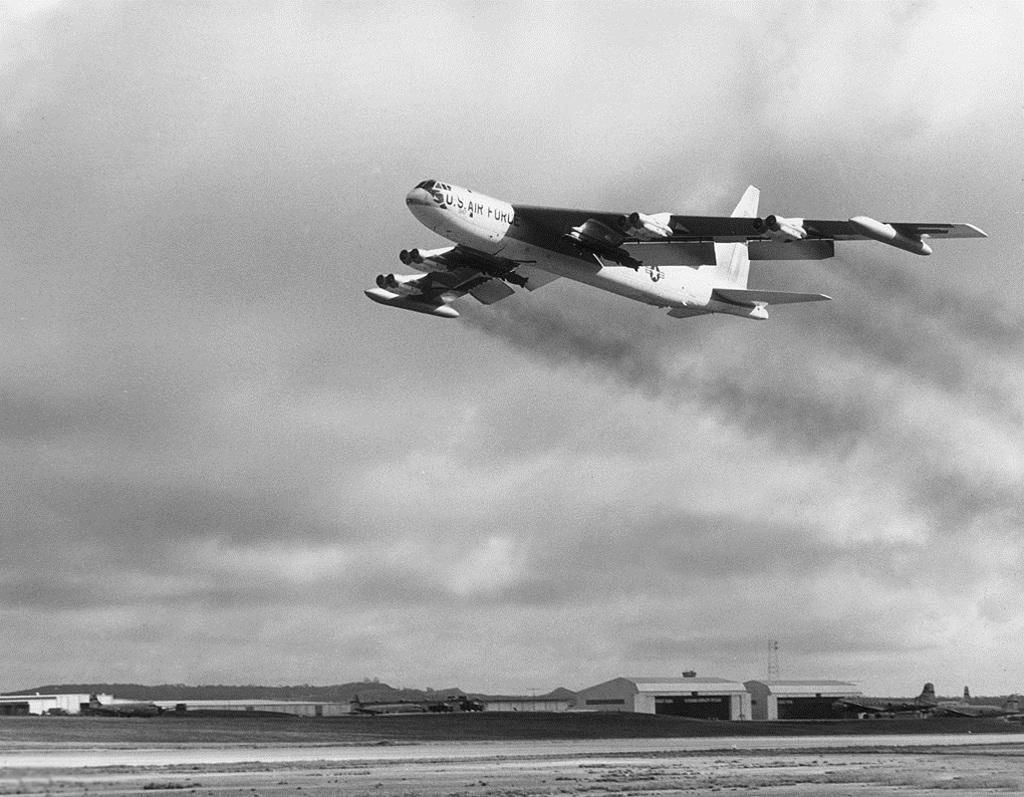What country is this plane from?
Your answer should be compact. Us. 